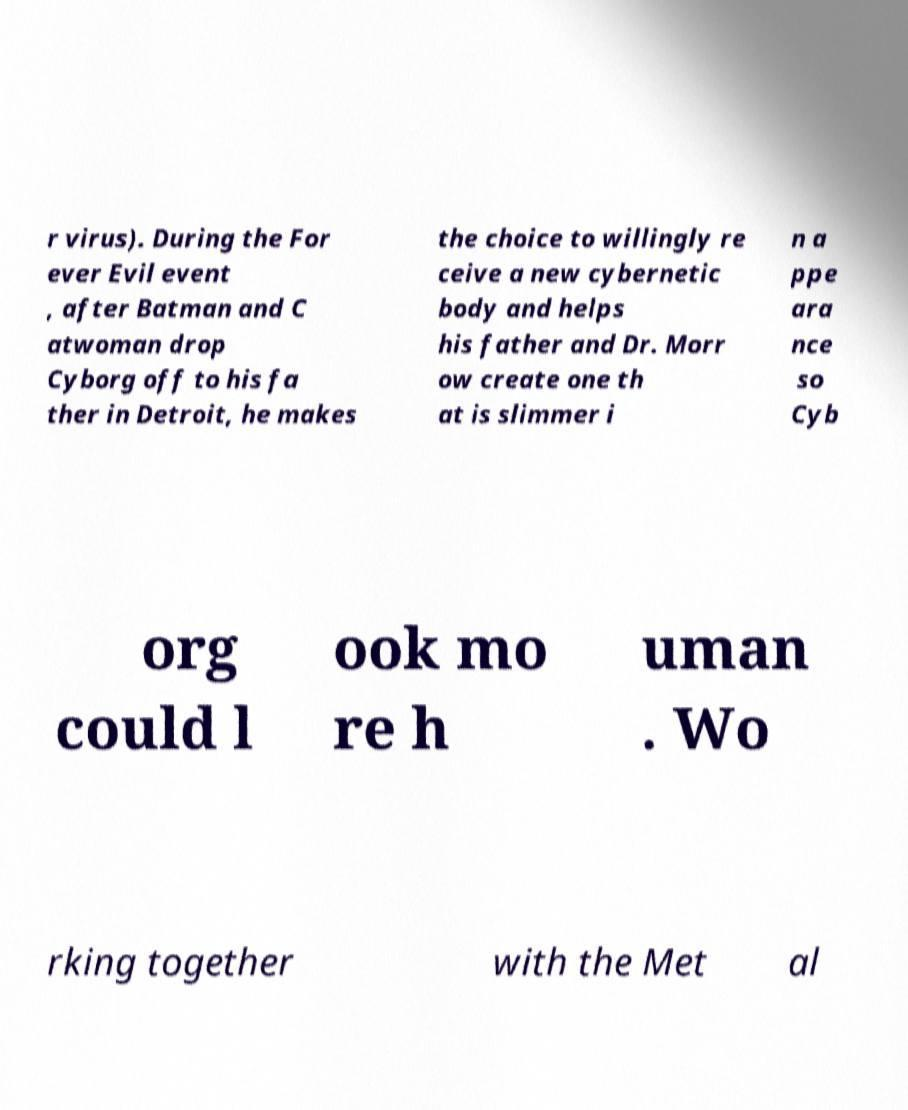Can you accurately transcribe the text from the provided image for me? r virus). During the For ever Evil event , after Batman and C atwoman drop Cyborg off to his fa ther in Detroit, he makes the choice to willingly re ceive a new cybernetic body and helps his father and Dr. Morr ow create one th at is slimmer i n a ppe ara nce so Cyb org could l ook mo re h uman . Wo rking together with the Met al 